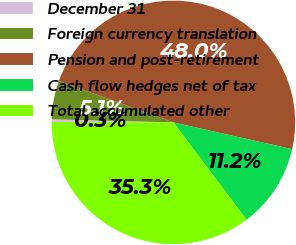Convert chart. <chart><loc_0><loc_0><loc_500><loc_500><pie_chart><fcel>December 31<fcel>Foreign currency translation<fcel>Pension and post-retirement<fcel>Cash flow hedges net of tax<fcel>Total accumulated other<nl><fcel>0.35%<fcel>5.12%<fcel>48.01%<fcel>11.2%<fcel>35.32%<nl></chart> 